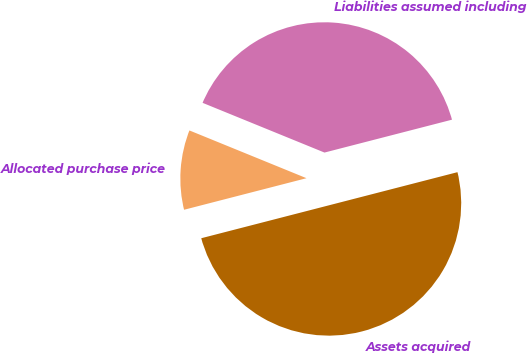Convert chart. <chart><loc_0><loc_0><loc_500><loc_500><pie_chart><fcel>Assets acquired<fcel>Liabilities assumed including<fcel>Allocated purchase price<nl><fcel>50.0%<fcel>39.82%<fcel>10.18%<nl></chart> 